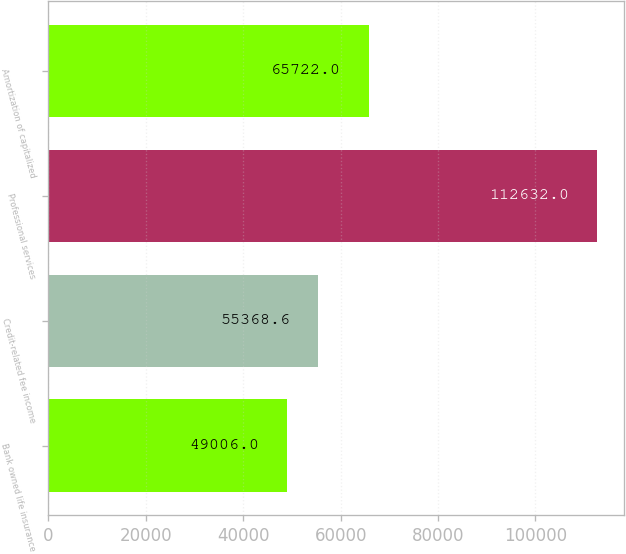<chart> <loc_0><loc_0><loc_500><loc_500><bar_chart><fcel>Bank owned life insurance<fcel>Credit-related fee income<fcel>Professional services<fcel>Amortization of capitalized<nl><fcel>49006<fcel>55368.6<fcel>112632<fcel>65722<nl></chart> 